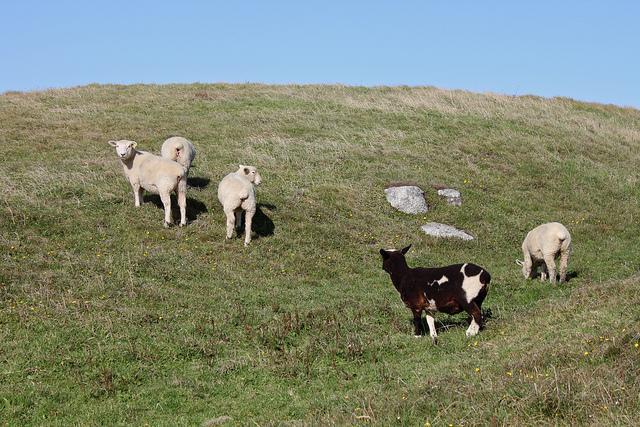How many white animals do you see?
Give a very brief answer. 4. How many sheep are eating?
Give a very brief answer. 2. How many animals are shown?
Give a very brief answer. 5. How many sheep are in the photo?
Give a very brief answer. 4. 